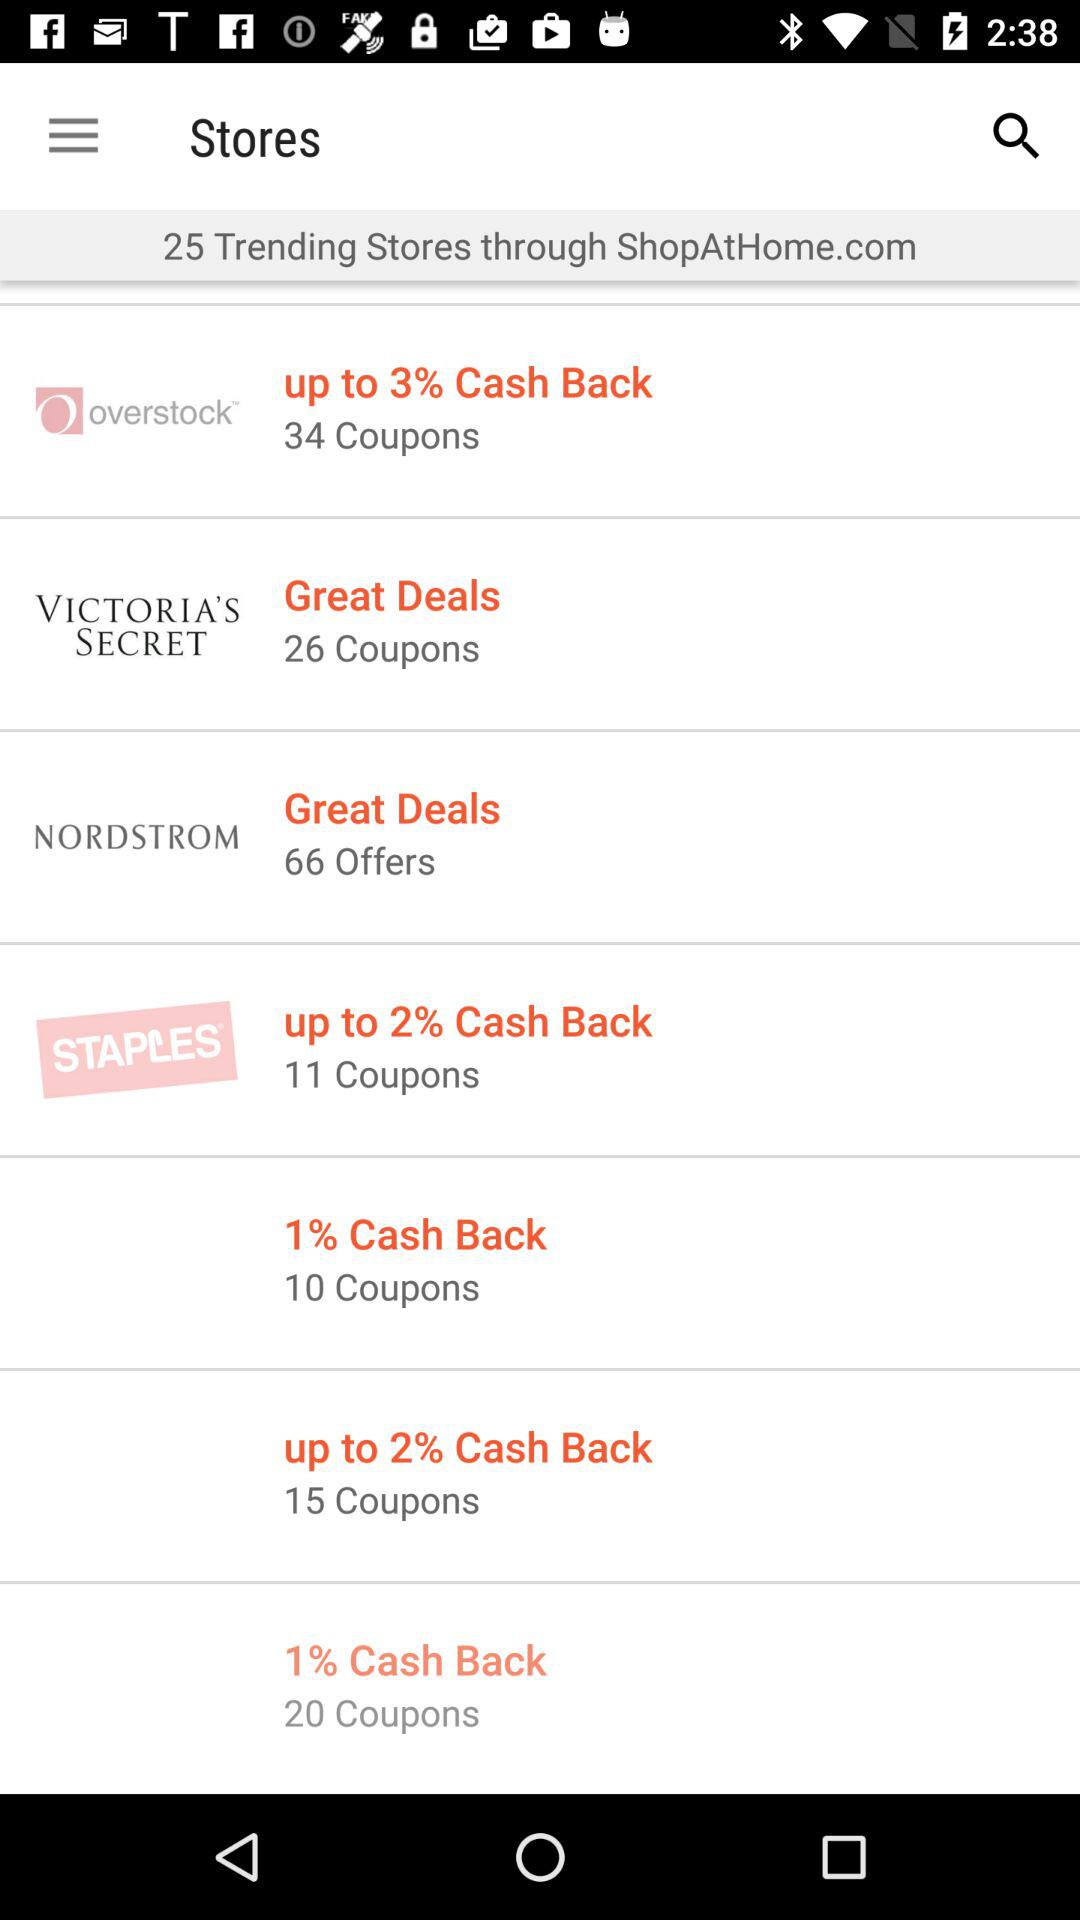How many coupons are there for "STAPLES"? There are 11 coupons. 